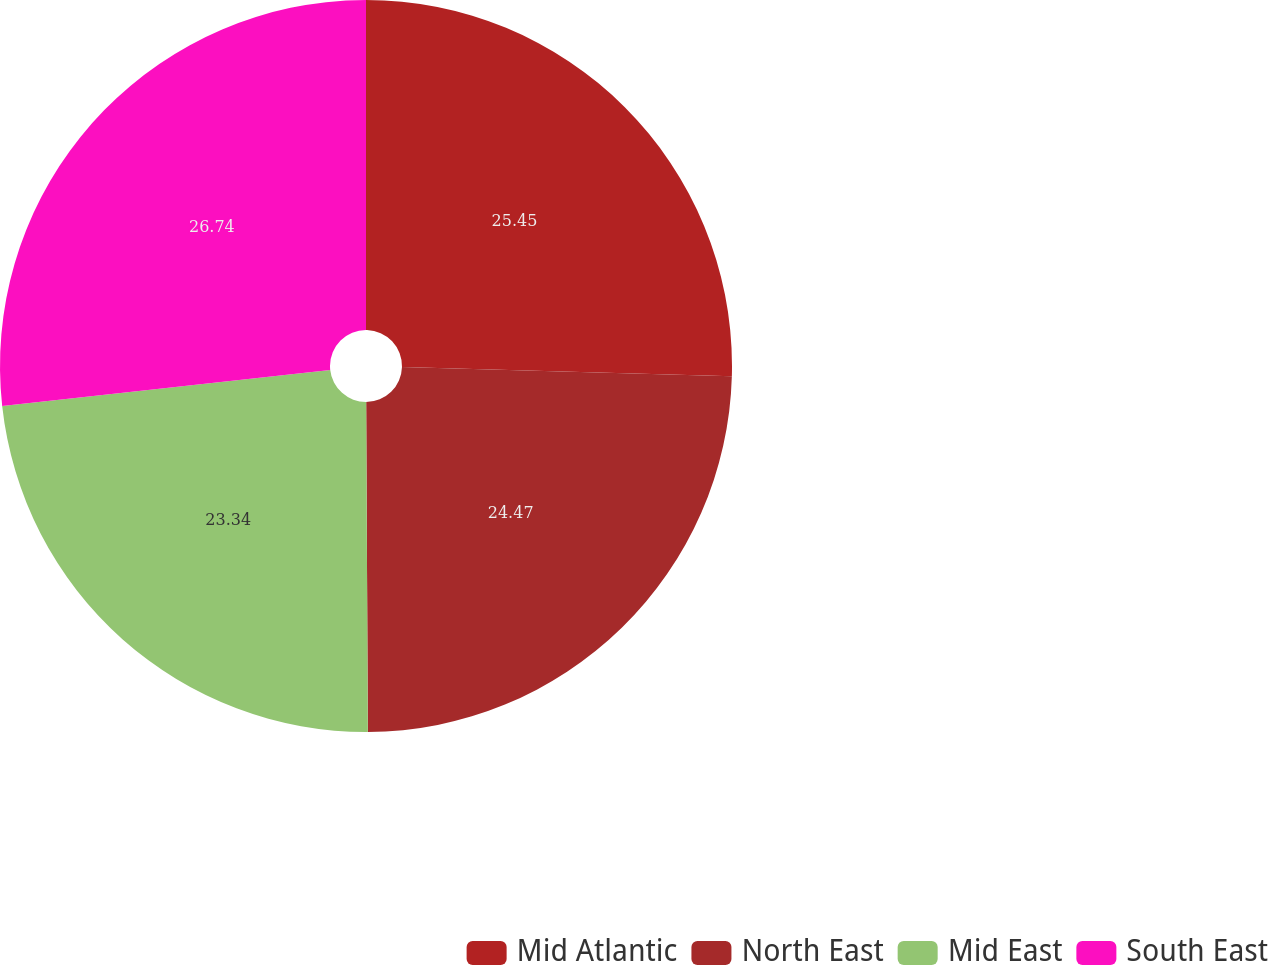Convert chart. <chart><loc_0><loc_0><loc_500><loc_500><pie_chart><fcel>Mid Atlantic<fcel>North East<fcel>Mid East<fcel>South East<nl><fcel>25.45%<fcel>24.47%<fcel>23.34%<fcel>26.74%<nl></chart> 